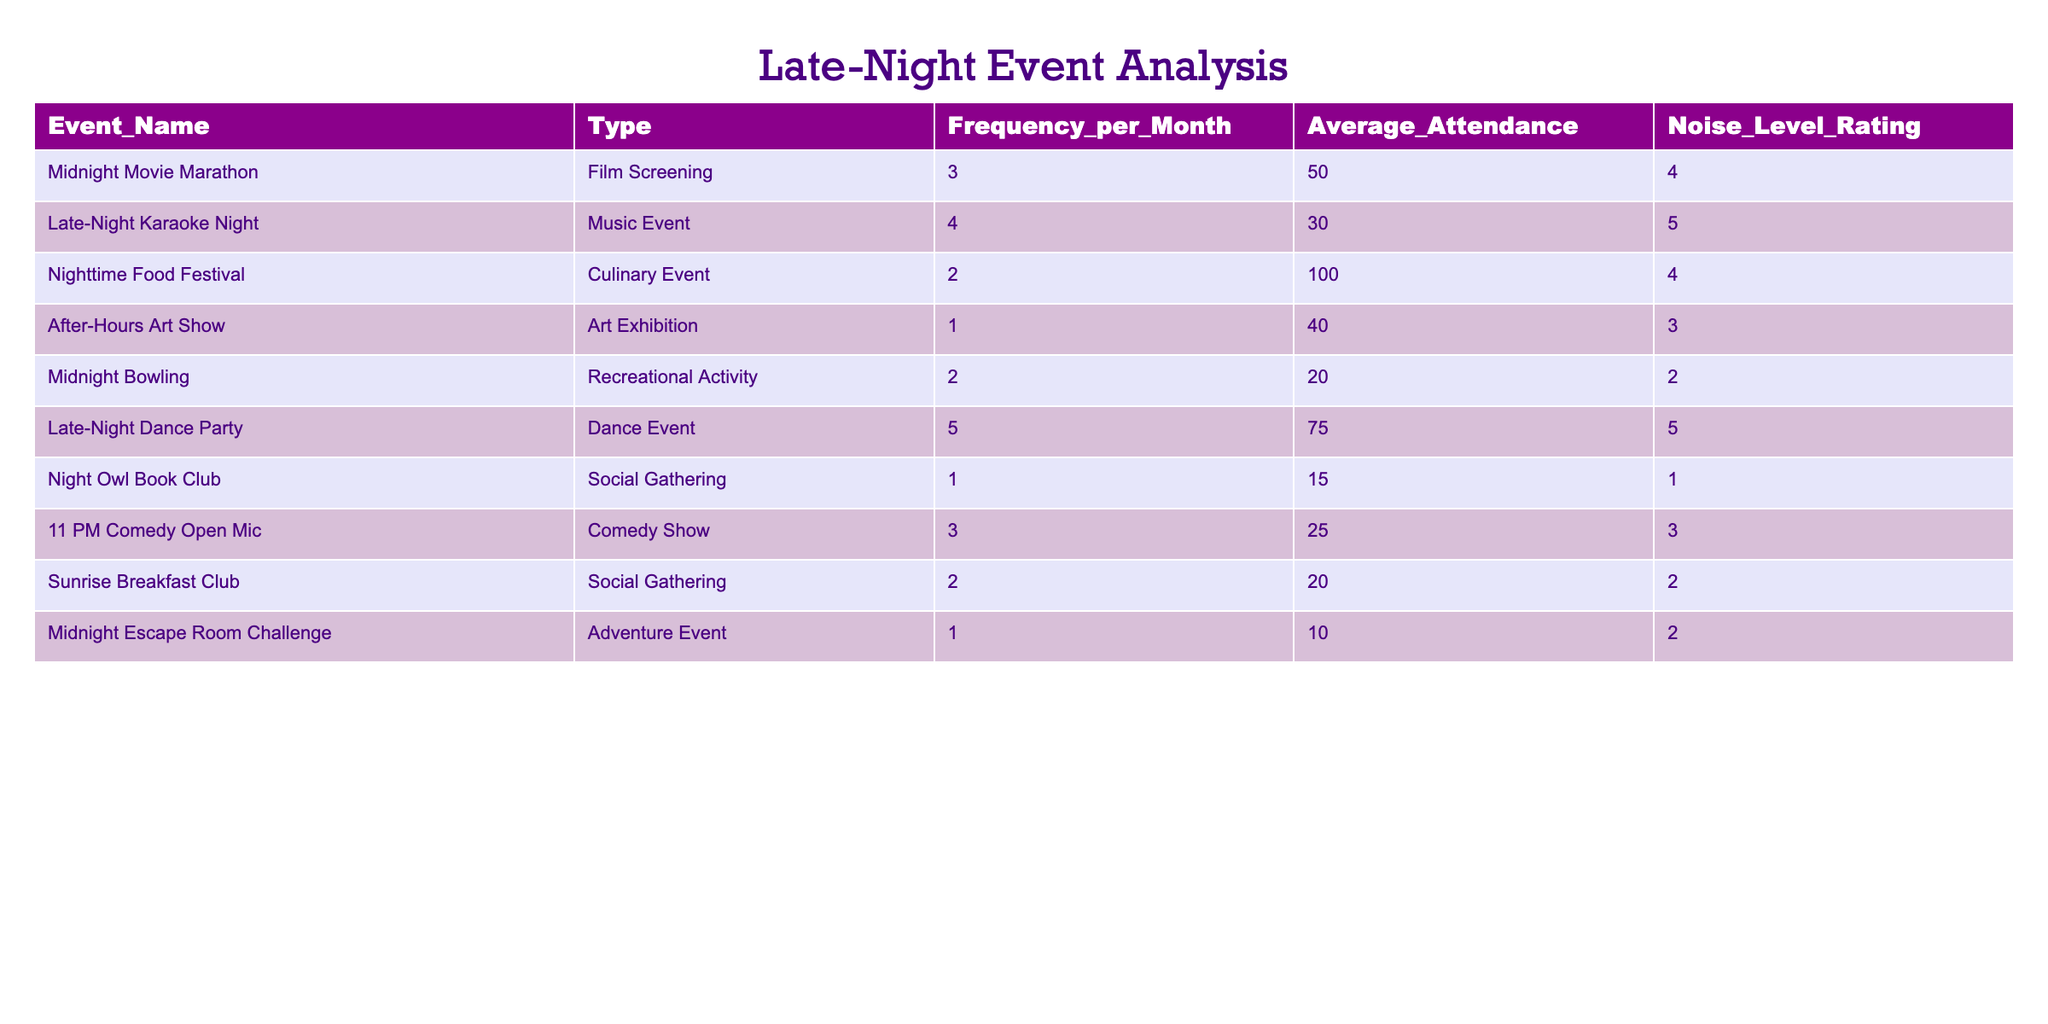What is the most frequent late-night event held? The table shows the frequency of various events per month. The "Late-Night Dance Party" has the highest frequency at 5 times per month.
Answer: Late-Night Dance Party Which event has the highest average attendance? By comparing the "Average_Attendance" values across all events, the "Nighttime Food Festival" has the highest number of attendees at 100.
Answer: Nighttime Food Festival How many total events are held in one month across all categories? We can calculate the total by summing the "Frequency_per_Month" column: 3 + 4 + 2 + 1 + 2 + 5 + 1 + 3 + 2 + 1 = 24. Thus, a total of 24 events are held.
Answer: 24 What is the average noise level rating of all events? To find the average noise level, sum the "Noise_Level_Rating" values and divide by the number of events. The sum is 4 + 5 + 4 + 3 + 2 + 5 + 1 + 3 + 2 + 2 = 31, and there are 10 events, so the average is 31 / 10 = 3.1.
Answer: 3.1 Is the "After-Hours Art Show" considered a loud event (noise level rating of 4 or more)? The "Noise_Level_Rating" for the "After-Hours Art Show" is 3, which is less than 4. Therefore, it is not considered loud.
Answer: No How many culinary events have higher noise levels than the "Midnight Bowling"? "Midnight Bowling" has a noise level rating of 2. The culinary events are "Nighttime Food Festival" with a rating of 4. Therefore, one culinary event has a higher noise level.
Answer: 1 What is the total average attendance for music events? The music events listed are "Late-Night Karaoke Night" and "Late-Night Dance Party," with average attendances of 30 and 75 respectively. Their total average attendance is (30 + 75) / 2 = 52.5.
Answer: 52.5 Which type of event has the highest overall frequency? "Dance Event" has an overall frequency of 5 (Late-Night Dance Party), whereas the other types have lower frequencies. Therefore, Dance Events are the most frequent type.
Answer: Dance Event Are there any events with a noise level rating of 1? Yes, the "Night Owl Book Club" has a noise level rating of 1.
Answer: Yes 